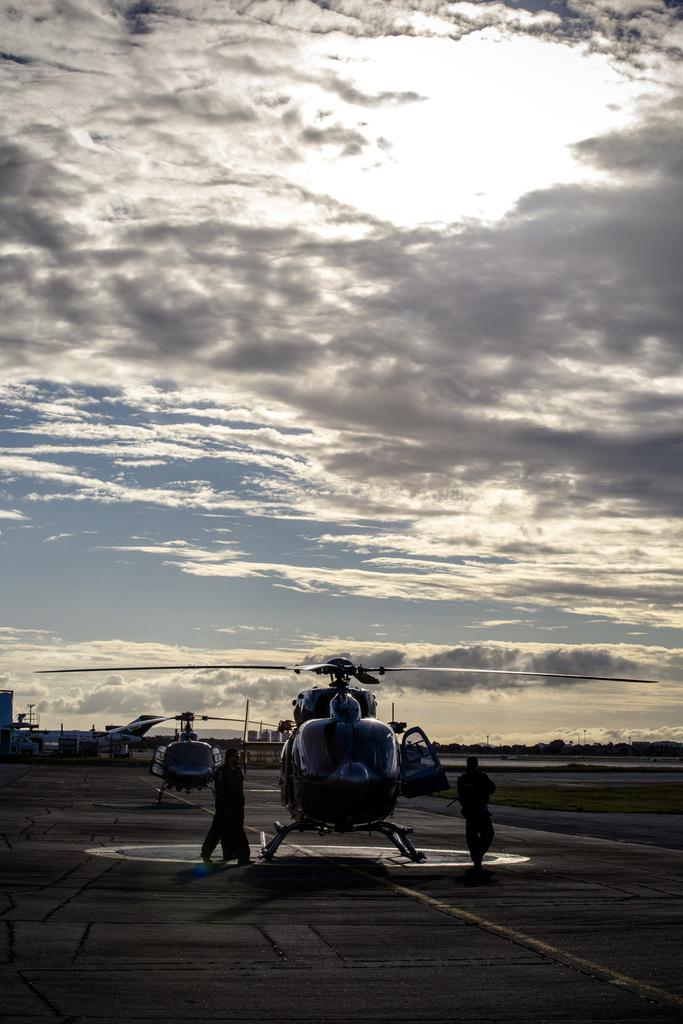What is the main subject of the image? The main subject of the image is helicopters. Where are the helicopters located in the image? The helicopters are standing on a runway road in the image. Are there any people present in the image? Yes, there are people standing near the helicopters. How would you describe the weather in the image? The sky is cloudy in the image. Can you see a crown on the helicopter in the image? No, there is no crown present on the helicopter in the image. What type of paint is being used by the people near the helicopters? There is no indication of paint or painting activity in the image. 